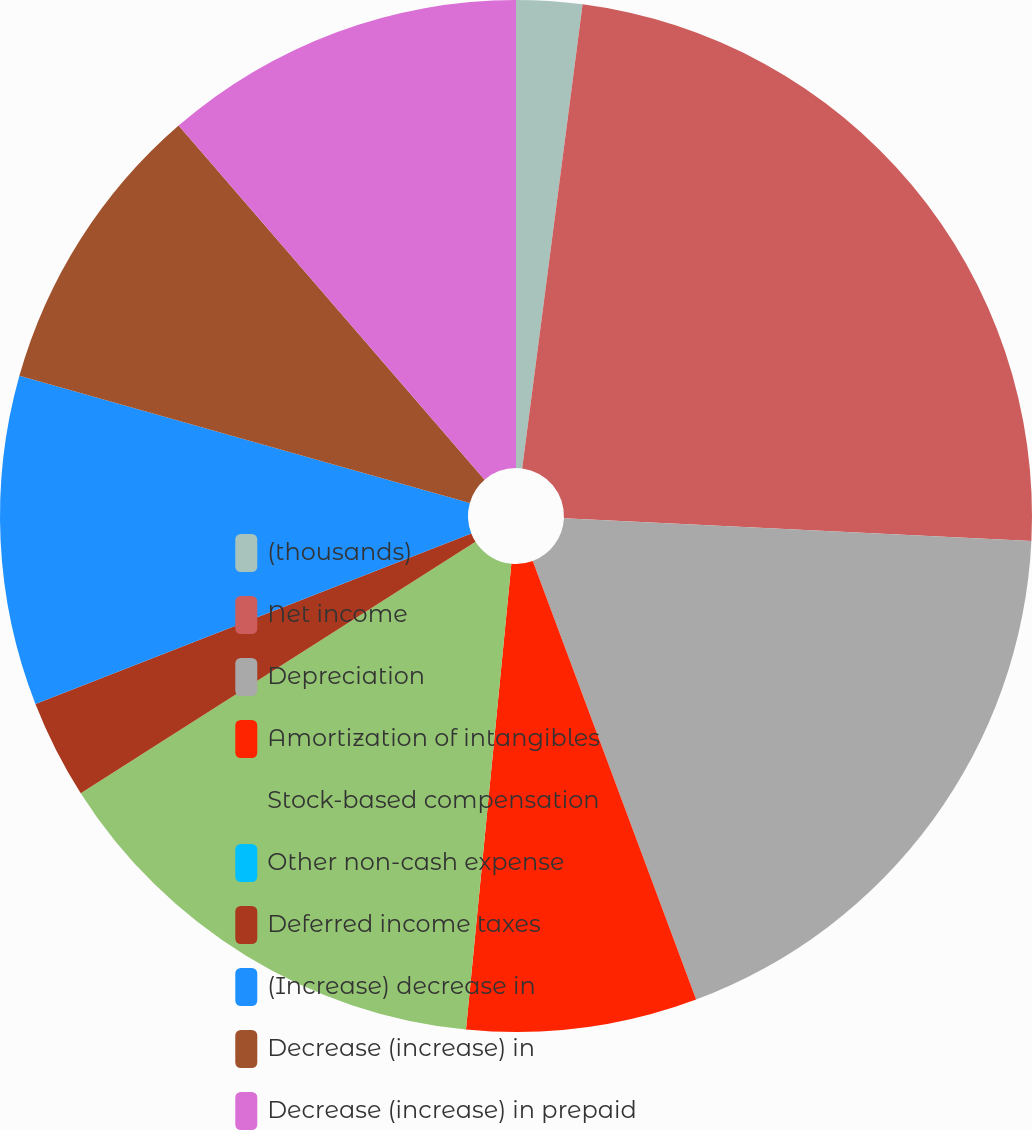Convert chart to OTSL. <chart><loc_0><loc_0><loc_500><loc_500><pie_chart><fcel>(thousands)<fcel>Net income<fcel>Depreciation<fcel>Amortization of intangibles<fcel>Stock-based compensation<fcel>Other non-cash expense<fcel>Deferred income taxes<fcel>(Increase) decrease in<fcel>Decrease (increase) in<fcel>Decrease (increase) in prepaid<nl><fcel>2.06%<fcel>23.71%<fcel>18.55%<fcel>7.22%<fcel>14.43%<fcel>0.0%<fcel>3.09%<fcel>10.31%<fcel>9.28%<fcel>11.34%<nl></chart> 